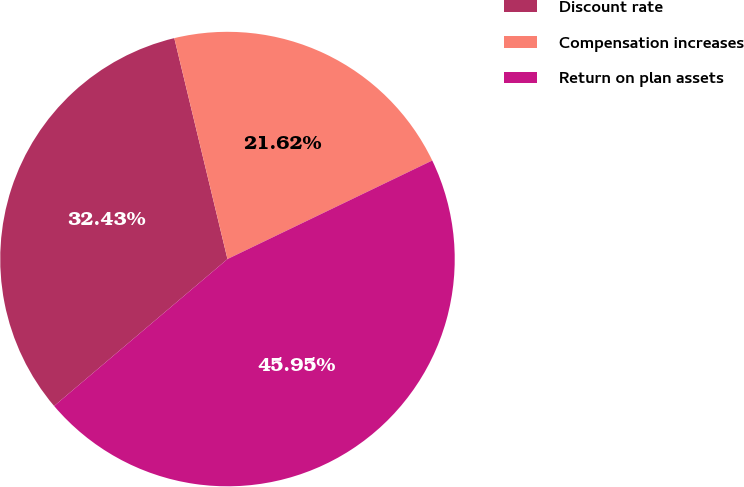Convert chart to OTSL. <chart><loc_0><loc_0><loc_500><loc_500><pie_chart><fcel>Discount rate<fcel>Compensation increases<fcel>Return on plan assets<nl><fcel>32.43%<fcel>21.62%<fcel>45.95%<nl></chart> 